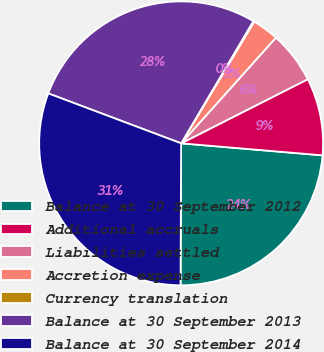Convert chart. <chart><loc_0><loc_0><loc_500><loc_500><pie_chart><fcel>Balance at 30 September 2012<fcel>Additional accruals<fcel>Liabilities settled<fcel>Accretion expense<fcel>Currency translation<fcel>Balance at 30 September 2013<fcel>Balance at 30 September 2014<nl><fcel>23.72%<fcel>8.81%<fcel>5.91%<fcel>3.02%<fcel>0.12%<fcel>27.77%<fcel>30.66%<nl></chart> 